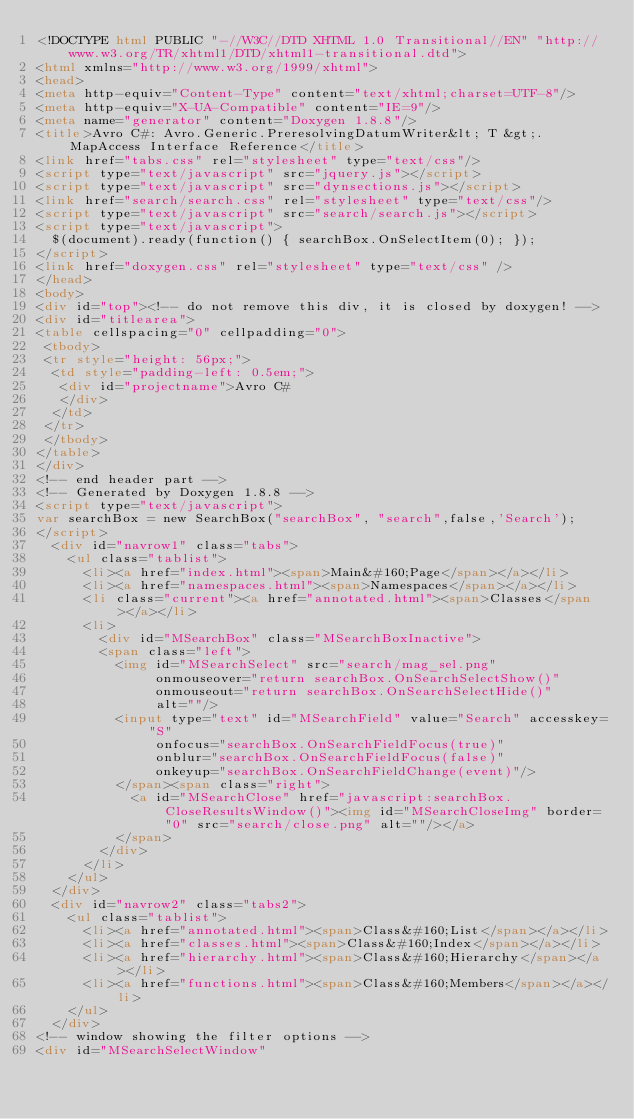Convert code to text. <code><loc_0><loc_0><loc_500><loc_500><_HTML_><!DOCTYPE html PUBLIC "-//W3C//DTD XHTML 1.0 Transitional//EN" "http://www.w3.org/TR/xhtml1/DTD/xhtml1-transitional.dtd">
<html xmlns="http://www.w3.org/1999/xhtml">
<head>
<meta http-equiv="Content-Type" content="text/xhtml;charset=UTF-8"/>
<meta http-equiv="X-UA-Compatible" content="IE=9"/>
<meta name="generator" content="Doxygen 1.8.8"/>
<title>Avro C#: Avro.Generic.PreresolvingDatumWriter&lt; T &gt;.MapAccess Interface Reference</title>
<link href="tabs.css" rel="stylesheet" type="text/css"/>
<script type="text/javascript" src="jquery.js"></script>
<script type="text/javascript" src="dynsections.js"></script>
<link href="search/search.css" rel="stylesheet" type="text/css"/>
<script type="text/javascript" src="search/search.js"></script>
<script type="text/javascript">
  $(document).ready(function() { searchBox.OnSelectItem(0); });
</script>
<link href="doxygen.css" rel="stylesheet" type="text/css" />
</head>
<body>
<div id="top"><!-- do not remove this div, it is closed by doxygen! -->
<div id="titlearea">
<table cellspacing="0" cellpadding="0">
 <tbody>
 <tr style="height: 56px;">
  <td style="padding-left: 0.5em;">
   <div id="projectname">Avro C#
   </div>
  </td>
 </tr>
 </tbody>
</table>
</div>
<!-- end header part -->
<!-- Generated by Doxygen 1.8.8 -->
<script type="text/javascript">
var searchBox = new SearchBox("searchBox", "search",false,'Search');
</script>
  <div id="navrow1" class="tabs">
    <ul class="tablist">
      <li><a href="index.html"><span>Main&#160;Page</span></a></li>
      <li><a href="namespaces.html"><span>Namespaces</span></a></li>
      <li class="current"><a href="annotated.html"><span>Classes</span></a></li>
      <li>
        <div id="MSearchBox" class="MSearchBoxInactive">
        <span class="left">
          <img id="MSearchSelect" src="search/mag_sel.png"
               onmouseover="return searchBox.OnSearchSelectShow()"
               onmouseout="return searchBox.OnSearchSelectHide()"
               alt=""/>
          <input type="text" id="MSearchField" value="Search" accesskey="S"
               onfocus="searchBox.OnSearchFieldFocus(true)" 
               onblur="searchBox.OnSearchFieldFocus(false)" 
               onkeyup="searchBox.OnSearchFieldChange(event)"/>
          </span><span class="right">
            <a id="MSearchClose" href="javascript:searchBox.CloseResultsWindow()"><img id="MSearchCloseImg" border="0" src="search/close.png" alt=""/></a>
          </span>
        </div>
      </li>
    </ul>
  </div>
  <div id="navrow2" class="tabs2">
    <ul class="tablist">
      <li><a href="annotated.html"><span>Class&#160;List</span></a></li>
      <li><a href="classes.html"><span>Class&#160;Index</span></a></li>
      <li><a href="hierarchy.html"><span>Class&#160;Hierarchy</span></a></li>
      <li><a href="functions.html"><span>Class&#160;Members</span></a></li>
    </ul>
  </div>
<!-- window showing the filter options -->
<div id="MSearchSelectWindow"</code> 